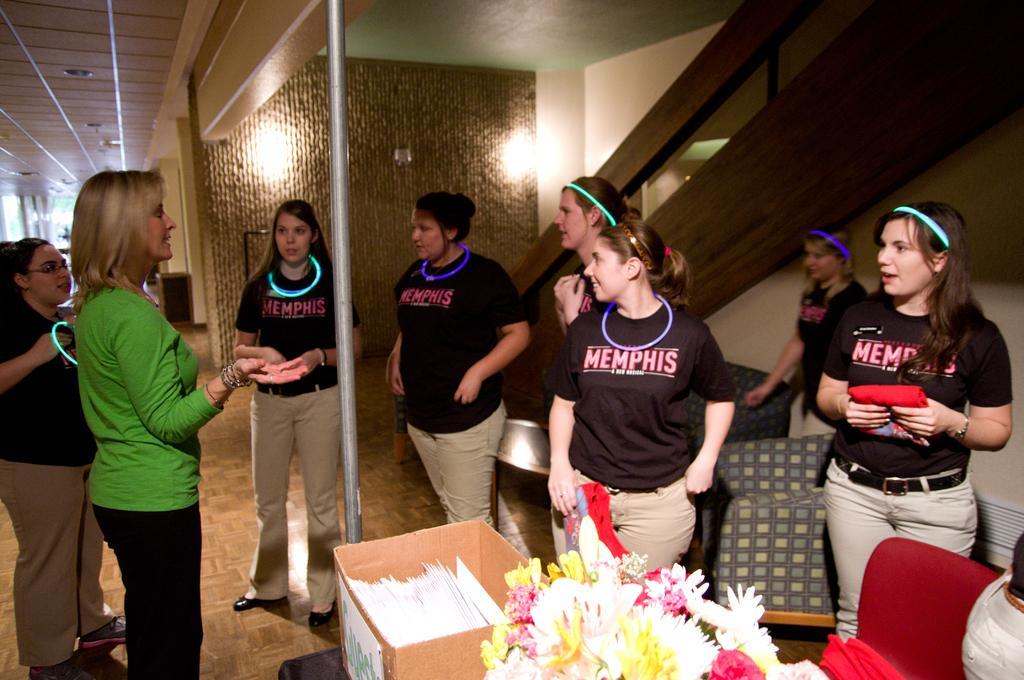How would you summarize this image in a sentence or two? In the foreground I can see a group of women´s are standing on the floor. At the bottom I can see bouquets, chairs and a cartoon box. In the background I can see a staircase, pole, wall and a rooftop. This image is taken in a hall. 